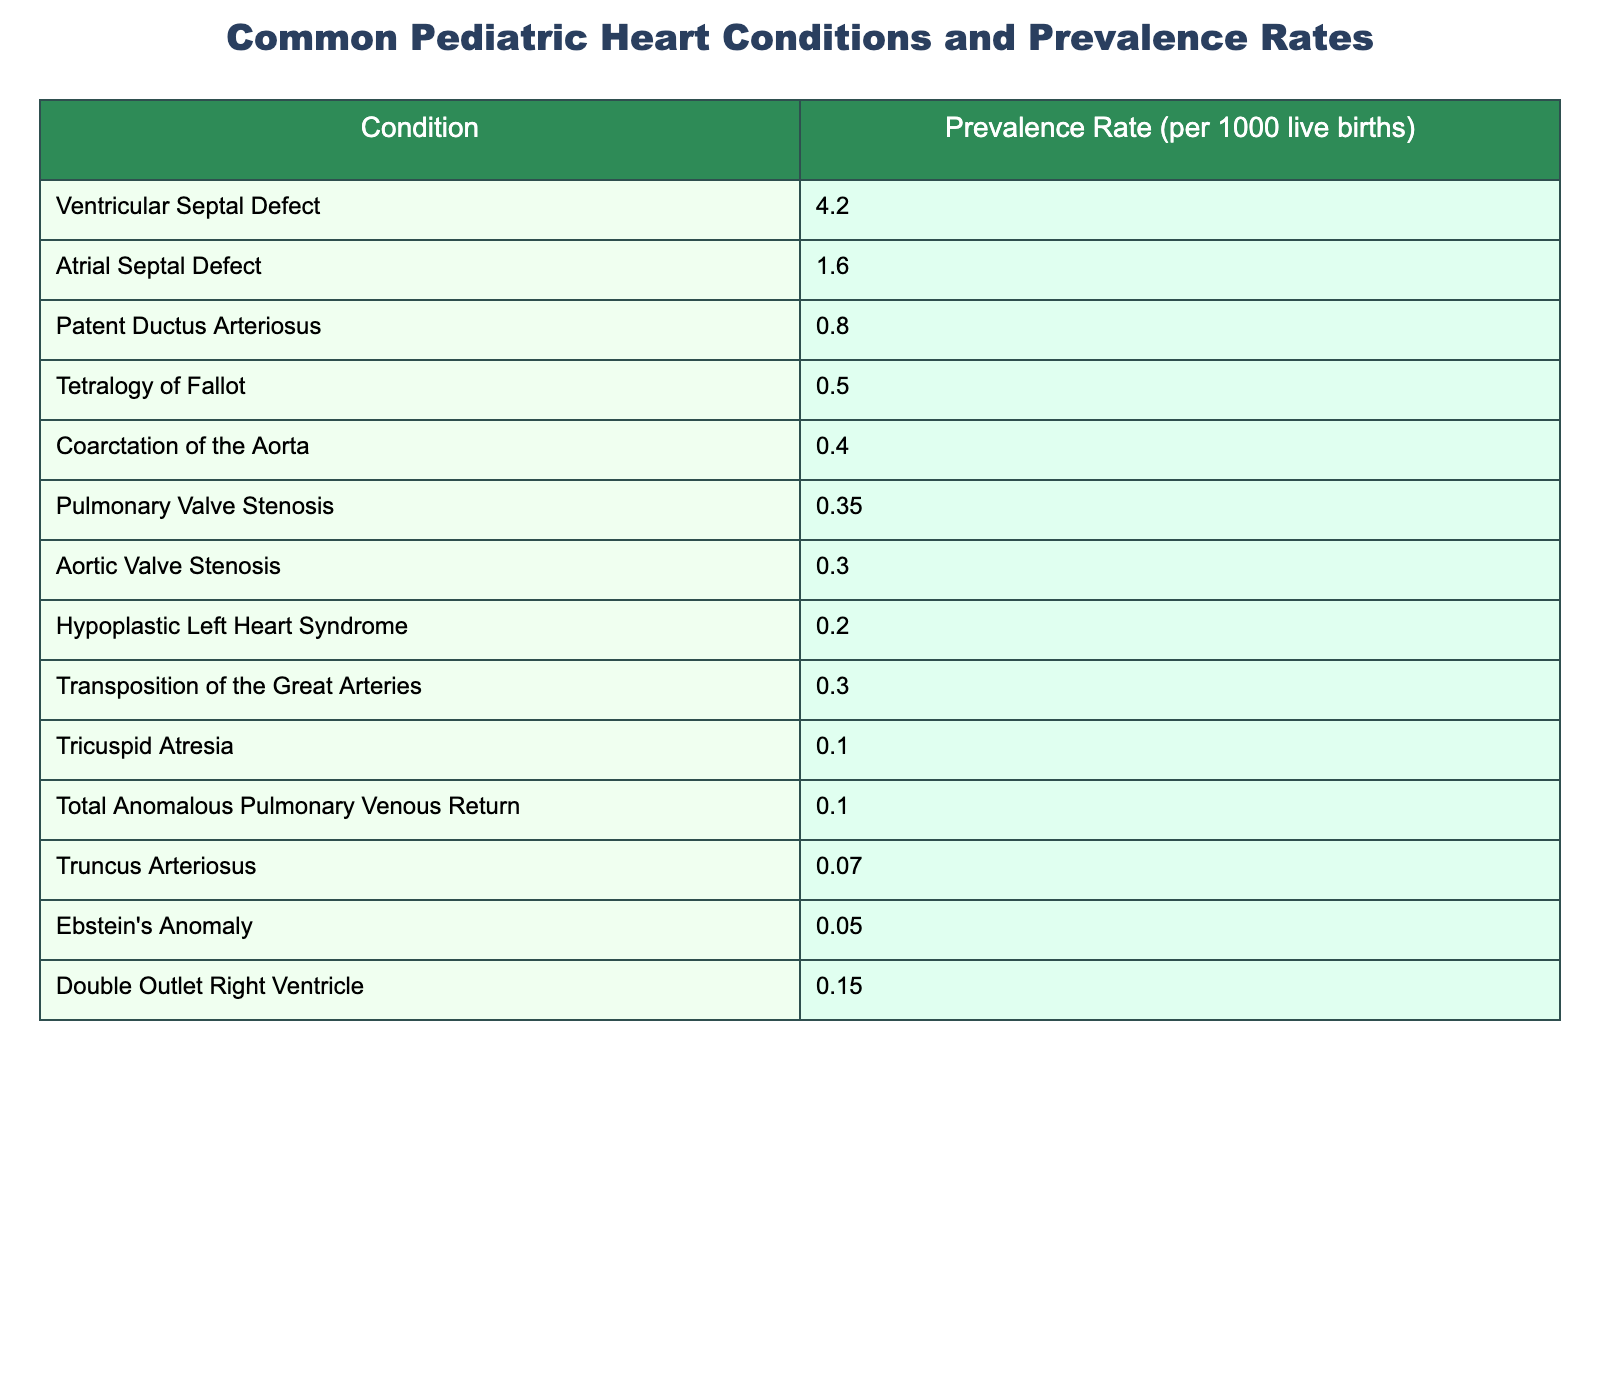What is the prevalence rate of Ventricular Septal Defect? The table lists Ventricular Septal Defect under the condition column and shows its prevalence rate as 4.2 per 1000 live births.
Answer: 4.2 Which condition has the lowest prevalence rate? Looking at the prevalence rates in the table, Truncus Arteriosus has the lowest prevalence rate at 0.07 per 1000 live births.
Answer: 0.07 What is the total prevalence rate of the three most common conditions? The three most common conditions listed, Ventricular Septal Defect (4.2), Atrial Septal Defect (1.6), and Patent Ductus Arteriosus (0.8), can be summed: 4.2 + 1.6 + 0.8 = 6.6 per 1000 live births.
Answer: 6.6 Is the prevalence rate of Aortic Valve Stenosis greater than that of Pulmonary Valve Stenosis? The prevalence rate for Aortic Valve Stenosis is 0.3, while for Pulmonary Valve Stenosis, it is 0.35. Since 0.3 < 0.35, the statement is false.
Answer: No What is the average prevalence rate of the heart conditions listed in the table? To find the average, we first add all the prevalence rates (4.2 + 1.6 + 0.8 + 0.5 + 0.4 + 0.35 + 0.3 + 0.2 + 0.3 + 0.1 + 0.1 + 0.07 + 0.05 + 0.15 = 8.99). Then, there are 14 conditions, so the average is 8.99 / 14 = approximately 0.642.
Answer: Approximately 0.642 Which condition has a prevalence rate closely matching 0.3? The table shows two conditions, Aortic Valve Stenosis (0.3) and Transposition of the Great Arteries (0.3), both matching the value of 0.3.
Answer: Aortic Valve Stenosis and Transposition of the Great Arteries How many conditions listed have a prevalence rate of less than 0.5? By checking the table, the conditions with prevalence rates less than 0.5 are: Tetralogy of Fallot (0.5), Coarctation of the Aorta (0.4), Pulmonary Valve Stenosis (0.35), Aortic Valve Stenosis (0.3), Hypoplastic Left Heart Syndrome (0.2), Tricuspid Atresia (0.1), Total Anomalous Pulmonary Venous Return (0.1), Truncus Arteriosus (0.07), Ebstein's Anomaly (0.05), and Double Outlet Right Ventricle (0.15). That's a total of 9 conditions.
Answer: 9 If we combine the prevalence rates of the two least common conditions, what do we get? We find the two least common conditions: Truncus Arteriosus (0.07) and Ebstein's Anomaly (0.05). When we add these rates together: 0.07 + 0.05 = 0.12.
Answer: 0.12 